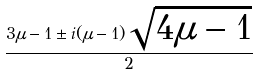<formula> <loc_0><loc_0><loc_500><loc_500>\frac { 3 \mu - 1 \pm i ( \mu - 1 ) \sqrt { 4 \mu - 1 } } { 2 }</formula> 